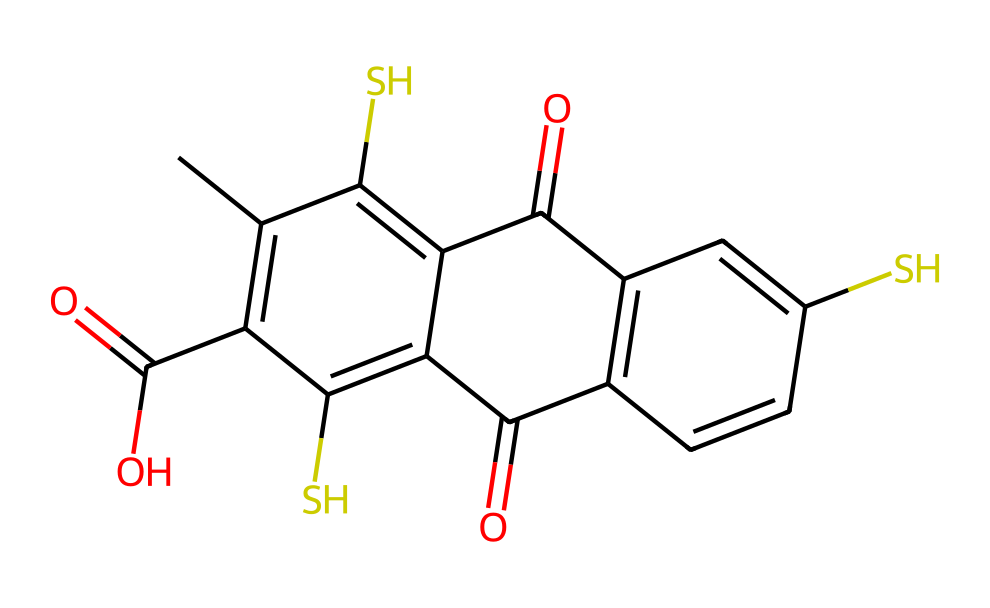What is the total number of sulfur atoms in this structure? By examining the provided SMILES representation, we can identify the sulfur (S) symbols within the structure. Counting them reveals that there are two sulfur atoms present in the compound.
Answer: two How many carbon atoms are present in this structure? The SMILES representation contains multiple 'C' symbols, which indicate carbon atoms. After counting all instances of 'C', it is determined that there are 11 carbon atoms in total in the structure.
Answer: eleven What functional groups can be identified in this compound? The SMILES shows various elements, including two carbonyl groups (C=O) and a carboxylic acid group (C(=O)O). These groups indicate the presence of both ketones and carboxylic acids in the structure.
Answer: ketones and carboxylic acids What type of bonding is primarily observed in this chemical structure? The chemical structure primarily consists of single bonds and double bonds between carbon and other atoms (like oxygen and sulfur). Analyzing the SMILES helps identify these bond types, notably C=O and C-S.
Answer: single and double bonds How does the presence of sulfur affect the color properties of this pigment? Sulfur often contributes to the vibrancy and stability of pigments. In this structure, the sulfur atoms play a role in the electronic interactions that impact light absorption, leading to specific color outputs when used in tattoo inks.
Answer: stability and vibrancy What is the molecular formula derived from the chemical structure? By counting each type of atom represented in the SMILES (C, H, O, S), we can derive the molecular formula as C11H8O4S2. This allows us to characterize the chemical composition clearly.
Answer: C11H8O4S2 